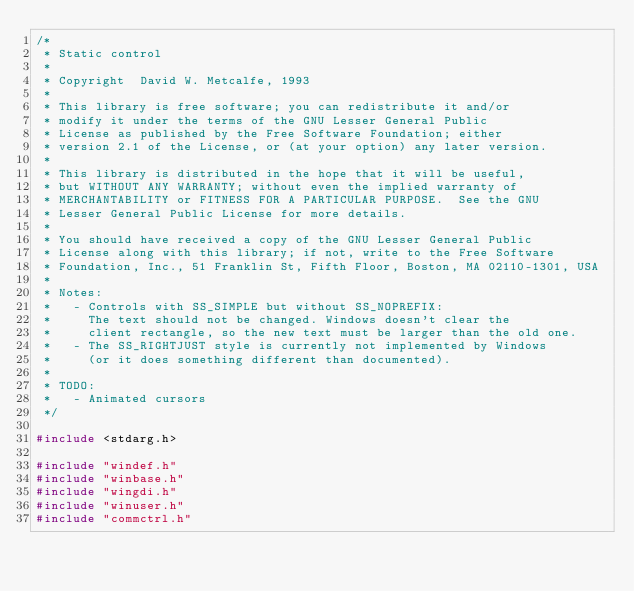<code> <loc_0><loc_0><loc_500><loc_500><_C_>/*
 * Static control
 *
 * Copyright  David W. Metcalfe, 1993
 *
 * This library is free software; you can redistribute it and/or
 * modify it under the terms of the GNU Lesser General Public
 * License as published by the Free Software Foundation; either
 * version 2.1 of the License, or (at your option) any later version.
 *
 * This library is distributed in the hope that it will be useful,
 * but WITHOUT ANY WARRANTY; without even the implied warranty of
 * MERCHANTABILITY or FITNESS FOR A PARTICULAR PURPOSE.  See the GNU
 * Lesser General Public License for more details.
 *
 * You should have received a copy of the GNU Lesser General Public
 * License along with this library; if not, write to the Free Software
 * Foundation, Inc., 51 Franklin St, Fifth Floor, Boston, MA 02110-1301, USA
 *
 * Notes:
 *   - Controls with SS_SIMPLE but without SS_NOPREFIX:
 *     The text should not be changed. Windows doesn't clear the
 *     client rectangle, so the new text must be larger than the old one.
 *   - The SS_RIGHTJUST style is currently not implemented by Windows
 *     (or it does something different than documented).
 *
 * TODO:
 *   - Animated cursors
 */

#include <stdarg.h>

#include "windef.h"
#include "winbase.h"
#include "wingdi.h"
#include "winuser.h"
#include "commctrl.h"</code> 